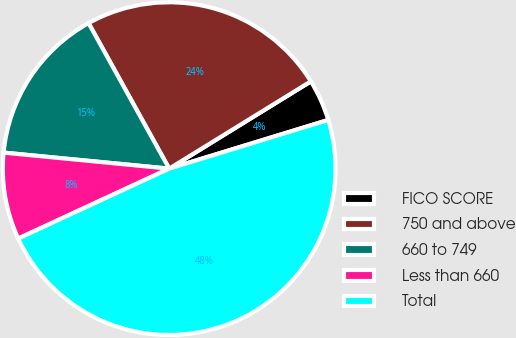Convert chart. <chart><loc_0><loc_0><loc_500><loc_500><pie_chart><fcel>FICO SCORE<fcel>750 and above<fcel>660 to 749<fcel>Less than 660<fcel>Total<nl><fcel>4.06%<fcel>24.26%<fcel>15.41%<fcel>8.44%<fcel>47.82%<nl></chart> 